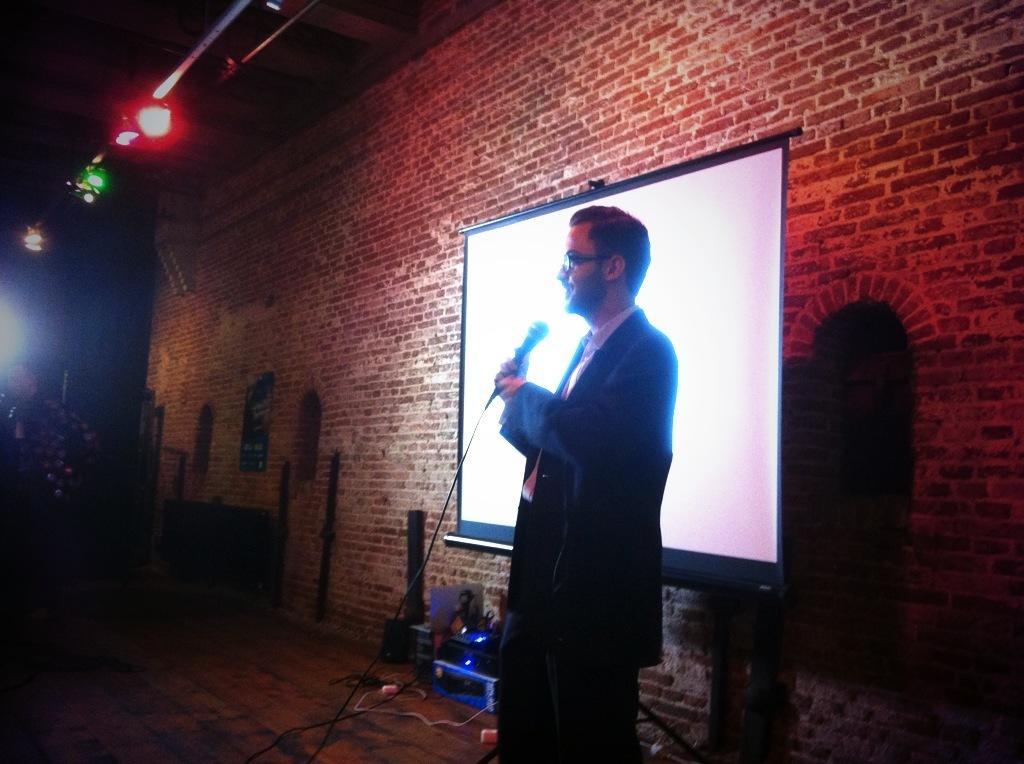Could you give a brief overview of what you see in this image? In this picture we can see a person wearing a spectacle and holding a microphone in his hand. There are a few wires and other objects are visible on the ground. We can see a projector screen and a poster on a brick wall. Some lights are visible on top. We can see a person on the left side. 